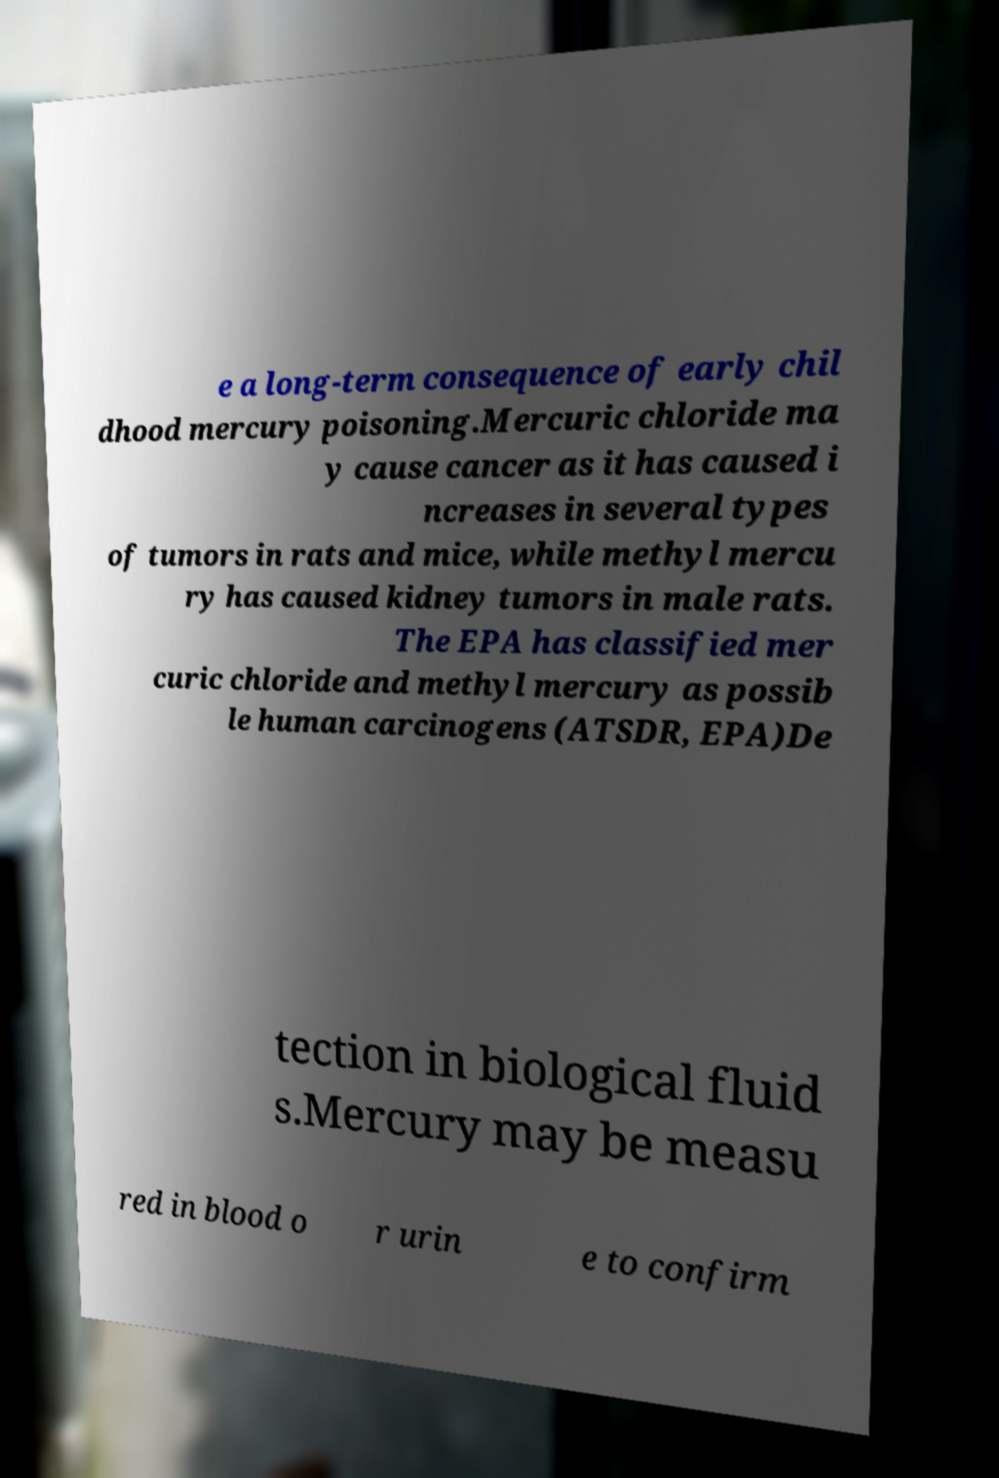There's text embedded in this image that I need extracted. Can you transcribe it verbatim? e a long-term consequence of early chil dhood mercury poisoning.Mercuric chloride ma y cause cancer as it has caused i ncreases in several types of tumors in rats and mice, while methyl mercu ry has caused kidney tumors in male rats. The EPA has classified mer curic chloride and methyl mercury as possib le human carcinogens (ATSDR, EPA)De tection in biological fluid s.Mercury may be measu red in blood o r urin e to confirm 